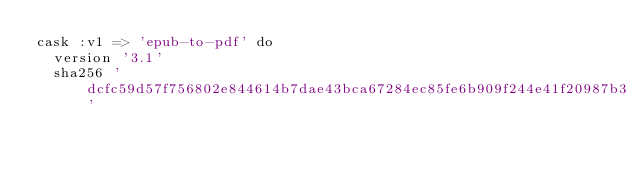Convert code to text. <code><loc_0><loc_0><loc_500><loc_500><_Ruby_>cask :v1 => 'epub-to-pdf' do
  version '3.1'
  sha256 'dcfc59d57f756802e844614b7dae43bca67284ec85fe6b909f244e41f20987b3'
</code> 